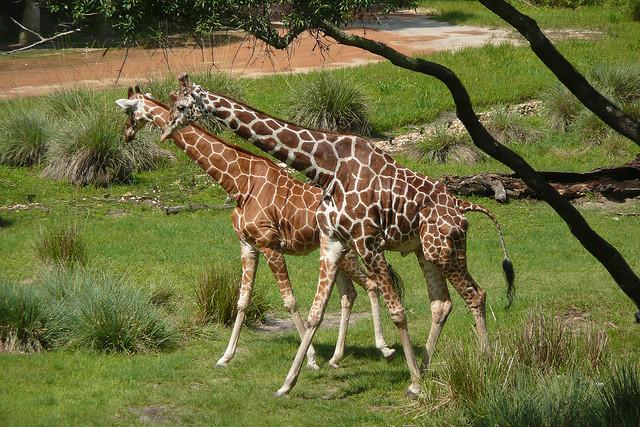Where are the two zebras in the picture?
Write a very short answer. There are no zebras. Is this how baby giraffes are made?
Keep it brief. No. How many giraffes?
Give a very brief answer. 2. Which giraffe appears closer?
Quick response, please. Dark one. Are they in a zoo?
Short answer required. No. How many giraffes are in this picture?
Short answer required. 2. Are they in a fenced area?
Answer briefly. No. Is there a lake in this photo?
Quick response, please. No. How many animals are there?
Quick response, please. 2. 